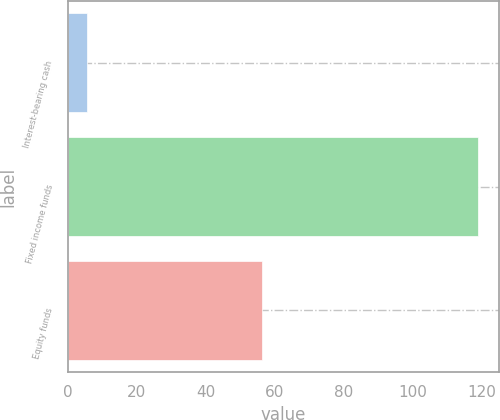Convert chart. <chart><loc_0><loc_0><loc_500><loc_500><bar_chart><fcel>Interest-bearing cash<fcel>Fixed income funds<fcel>Equity funds<nl><fcel>5.7<fcel>119<fcel>56.3<nl></chart> 